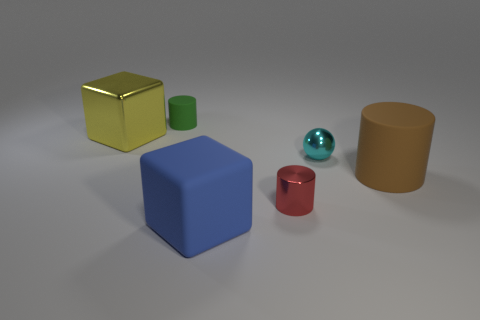What material is the tiny cyan ball that is in front of the block that is behind the small metallic thing to the right of the metal cylinder?
Provide a succinct answer. Metal. How many other things are there of the same size as the shiny ball?
Make the answer very short. 2. There is a small red object that is the same shape as the brown rubber thing; what material is it?
Provide a short and direct response. Metal. The shiny block is what color?
Your answer should be compact. Yellow. The big block that is to the right of the tiny thing that is behind the yellow thing is what color?
Your response must be concise. Blue. How many small cylinders are in front of the tiny thing behind the large cube to the left of the big blue object?
Offer a terse response. 1. There is a tiny cyan shiny thing; are there any metallic things behind it?
Provide a short and direct response. Yes. Is there any other thing that has the same color as the large cylinder?
Provide a short and direct response. No. What number of spheres are tiny red objects or tiny matte things?
Ensure brevity in your answer.  0. What number of matte cylinders are in front of the small cyan ball and to the left of the brown thing?
Ensure brevity in your answer.  0. 